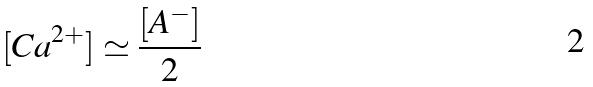Convert formula to latex. <formula><loc_0><loc_0><loc_500><loc_500>[ C a ^ { 2 + } ] \simeq \frac { [ A ^ { - } ] } { 2 }</formula> 